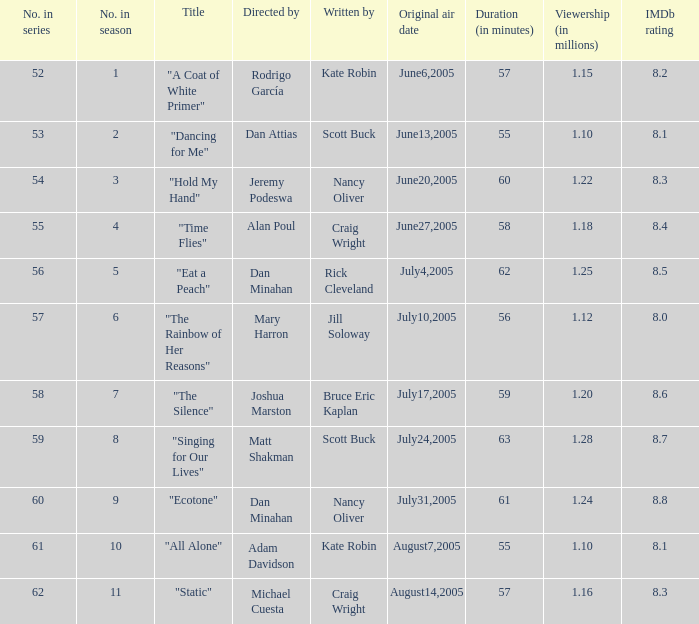What date was episode 10 in the season originally aired? August7,2005. 